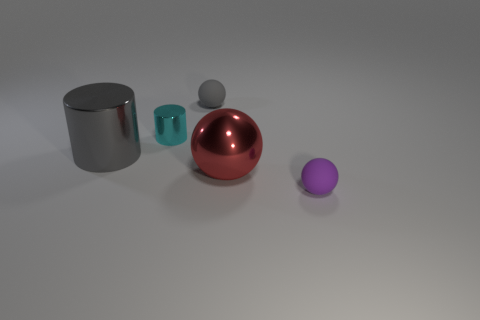Is the number of red objects behind the tiny gray rubber sphere greater than the number of big gray shiny cylinders to the right of the tiny metallic thing?
Your response must be concise. No. There is a small thing to the right of the gray sphere; is its color the same as the tiny metal object?
Provide a succinct answer. No. The purple rubber object has what size?
Offer a very short reply. Small. There is a gray sphere that is the same size as the cyan metallic cylinder; what is its material?
Give a very brief answer. Rubber. What is the color of the tiny rubber sphere on the left side of the metal ball?
Make the answer very short. Gray. What number of small yellow spheres are there?
Your answer should be very brief. 0. There is a tiny ball that is left of the purple matte object right of the big metal ball; is there a red metal ball on the right side of it?
Ensure brevity in your answer.  Yes. The cyan object that is the same size as the purple sphere is what shape?
Your response must be concise. Cylinder. What number of other objects are there of the same color as the tiny metallic cylinder?
Keep it short and to the point. 0. What is the material of the small purple ball?
Give a very brief answer. Rubber. 